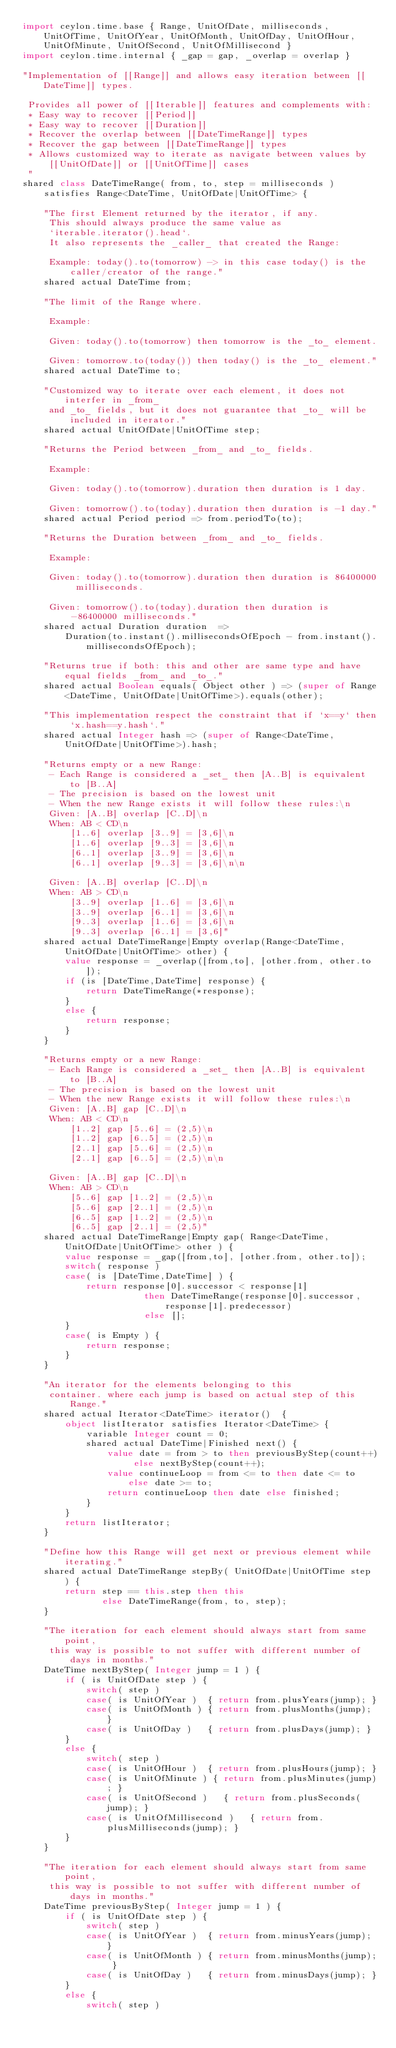<code> <loc_0><loc_0><loc_500><loc_500><_Ceylon_>import ceylon.time.base { Range, UnitOfDate, milliseconds, UnitOfTime, UnitOfYear, UnitOfMonth, UnitOfDay, UnitOfHour, UnitOfMinute, UnitOfSecond, UnitOfMillisecond }
import ceylon.time.internal { _gap = gap, _overlap = overlap }

"Implementation of [[Range]] and allows easy iteration between [[DateTime]] types.
 
 Provides all power of [[Iterable]] features and complements with:
 * Easy way to recover [[Period]]
 * Easy way to recover [[Duration]]
 * Recover the overlap between [[DateTimeRange]] types
 * Recover the gap between [[DateTimeRange]] types
 * Allows customized way to iterate as navigate between values by [[UnitOfDate]] or [[UnitOfTime]] cases
 "
shared class DateTimeRange( from, to, step = milliseconds ) satisfies Range<DateTime, UnitOfDate|UnitOfTime> {

    "The first Element returned by the iterator, if any.
     This should always produce the same value as
     `iterable.iterator().head`.
     It also represents the _caller_ that created the Range:
     
     Example: today().to(tomorrow) -> in this case today() is the caller/creator of the range."
    shared actual DateTime from;

    "The limit of the Range where. 

     Example:

     Given: today().to(tomorrow) then tomorrow is the _to_ element.
     
     Given: tomorrow.to(today()) then today() is the _to_ element."
    shared actual DateTime to;

    "Customized way to iterate over each element, it does not interfer in _from_
     and _to_ fields, but it does not guarantee that _to_ will be included in iterator."
    shared actual UnitOfDate|UnitOfTime step;

    "Returns the Period between _from_ and _to_ fields.

     Example: 
     
     Given: today().to(tomorrow).duration then duration is 1 day.
     
     Given: tomorrow().to(today).duration then duration is -1 day."
    shared actual Period period => from.periodTo(to);    

    "Returns the Duration between _from_ and _to_ fields.

     Example: 
     
     Given: today().to(tomorrow).duration then duration is 86400000 milliseconds.
     
     Given: tomorrow().to(today).duration then duration is -86400000 milliseconds."
    shared actual Duration duration  =>
        Duration(to.instant().millisecondsOfEpoch - from.instant().millisecondsOfEpoch);

    "Returns true if both: this and other are same type and have equal fields _from_ and _to_."
    shared actual Boolean equals( Object other ) => (super of Range<DateTime, UnitOfDate|UnitOfTime>).equals(other); 

    "This implementation respect the constraint that if `x==y` then `x.hash==y.hash`."
    shared actual Integer hash => (super of Range<DateTime, UnitOfDate|UnitOfTime>).hash;

    "Returns empty or a new Range:
     - Each Range is considered a _set_ then [A..B] is equivalent to [B..A] 
     - The precision is based on the lowest unit 
     - When the new Range exists it will follow these rules:\n
     Given: [A..B] overlap [C..D]\n 
     When: AB < CD\n
         [1..6] overlap [3..9] = [3,6]\n
         [1..6] overlap [9..3] = [3,6]\n
         [6..1] overlap [3..9] = [3,6]\n
         [6..1] overlap [9..3] = [3,6]\n\n

     Given: [A..B] overlap [C..D]\n 
     When: AB > CD\n
         [3..9] overlap [1..6] = [3,6]\n
         [3..9] overlap [6..1] = [3,6]\n
         [9..3] overlap [1..6] = [3,6]\n
         [9..3] overlap [6..1] = [3,6]"
    shared actual DateTimeRange|Empty overlap(Range<DateTime, UnitOfDate|UnitOfTime> other) {
        value response = _overlap([from,to], [other.from, other.to]);
        if (is [DateTime,DateTime] response) {
            return DateTimeRange(*response);
        }
        else {
            return response;
        }
    }

    "Returns empty or a new Range:
     - Each Range is considered a _set_ then [A..B] is equivalent to [B..A] 
     - The precision is based on the lowest unit 
     - When the new Range exists it will follow these rules:\n
     Given: [A..B] gap [C..D]\n 
     When: AB < CD\n
         [1..2] gap [5..6] = (2,5)\n
         [1..2] gap [6..5] = (2,5)\n
         [2..1] gap [5..6] = (2,5)\n
         [2..1] gap [6..5] = (2,5)\n\n

     Given: [A..B] gap [C..D]\n 
     When: AB > CD\n
         [5..6] gap [1..2] = (2,5)\n
         [5..6] gap [2..1] = (2,5)\n
         [6..5] gap [1..2] = (2,5)\n
         [6..5] gap [2..1] = (2,5)"
    shared actual DateTimeRange|Empty gap( Range<DateTime, UnitOfDate|UnitOfTime> other ) {
        value response = _gap([from,to], [other.from, other.to]);
        switch( response )
        case( is [DateTime,DateTime] ) {
            return response[0].successor < response[1] 
                       then DateTimeRange(response[0].successor, response[1].predecessor)
                       else [];
        }
        case( is Empty ) {
            return response;
        }
    }

    "An iterator for the elements belonging to this 
     container. where each jump is based on actual step of this Range."
    shared actual Iterator<DateTime> iterator()  {
        object listIterator satisfies Iterator<DateTime> {
            variable Integer count = 0;
            shared actual DateTime|Finished next() {
                value date = from > to then previousByStep(count++) else nextByStep(count++);
                value continueLoop = from <= to then date <= to else date >= to;
                return continueLoop then date else finished;
            }
        }
        return listIterator;
    }

    "Define how this Range will get next or previous element while iterating."
    shared actual DateTimeRange stepBy( UnitOfDate|UnitOfTime step ) {
        return step == this.step then this 
               else DateTimeRange(from, to, step);
    }

    "The iteration for each element should always start from same point,
     this way is possible to not suffer with different number of days in months."
    DateTime nextByStep( Integer jump = 1 ) {
        if ( is UnitOfDate step ) {
            switch( step )
            case( is UnitOfYear )  { return from.plusYears(jump); }
            case( is UnitOfMonth ) { return from.plusMonths(jump); }
            case( is UnitOfDay )   { return from.plusDays(jump); }
        }
        else {
            switch( step )
            case( is UnitOfHour )  { return from.plusHours(jump); }
            case( is UnitOfMinute ) { return from.plusMinutes(jump); }
            case( is UnitOfSecond )   { return from.plusSeconds(jump); }
            case( is UnitOfMillisecond )   { return from.plusMilliseconds(jump); }
        }
    }

    "The iteration for each element should always start from same point,
     this way is possible to not suffer with different number of days in months."
    DateTime previousByStep( Integer jump = 1 ) {
        if ( is UnitOfDate step ) {
            switch( step )
            case( is UnitOfYear )  { return from.minusYears(jump); }
            case( is UnitOfMonth ) { return from.minusMonths(jump); }
            case( is UnitOfDay )   { return from.minusDays(jump); }
        }
        else {
            switch( step )</code> 